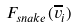Convert formula to latex. <formula><loc_0><loc_0><loc_500><loc_500>F _ { s n a k e } ( \overline { v } _ { i } )</formula> 